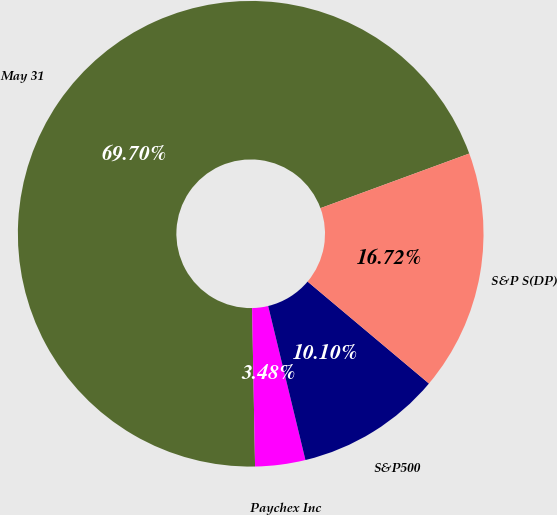Convert chart to OTSL. <chart><loc_0><loc_0><loc_500><loc_500><pie_chart><fcel>May 31<fcel>Paychex Inc<fcel>S&P500<fcel>S&P S(DP)<nl><fcel>69.7%<fcel>3.48%<fcel>10.1%<fcel>16.72%<nl></chart> 